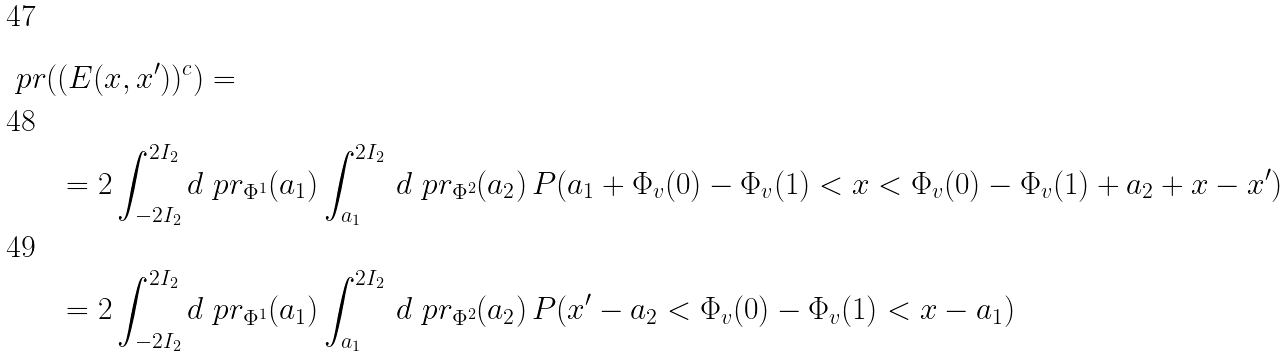<formula> <loc_0><loc_0><loc_500><loc_500>\ p r ( & ( E ( x , x ^ { \prime } ) ) ^ { c } ) = \\ & = 2 \int _ { - 2 I _ { 2 } } ^ { 2 I _ { 2 } } d \ p r _ { \Phi ^ { 1 } } ( a _ { 1 } ) \int _ { a _ { 1 } } ^ { 2 I _ { 2 } } \, d \ p r _ { \Phi ^ { 2 } } ( a _ { 2 } ) \, P ( a _ { 1 } + \Phi _ { v } ( 0 ) - \Phi _ { v } ( 1 ) < x < \Phi _ { v } ( 0 ) - \Phi _ { v } ( 1 ) + a _ { 2 } + x - x ^ { \prime } ) \\ & = 2 \int _ { - 2 I _ { 2 } } ^ { 2 I _ { 2 } } d \ p r _ { \Phi ^ { 1 } } ( a _ { 1 } ) \int _ { a _ { 1 } } ^ { 2 I _ { 2 } } \, d \ p r _ { \Phi ^ { 2 } } ( a _ { 2 } ) \, P ( x ^ { \prime } - a _ { 2 } < \Phi _ { v } ( 0 ) - \Phi _ { v } ( 1 ) < x - a _ { 1 } )</formula> 